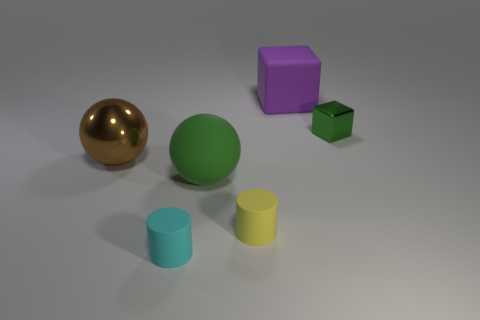There is a thing that is both left of the green shiny object and behind the large brown object; what is its size?
Your answer should be compact. Large. There is a purple block; are there any big shiny spheres to the left of it?
Keep it short and to the point. Yes. There is a large brown metal sphere left of the purple matte cube; are there any tiny matte things right of it?
Give a very brief answer. Yes. Are there an equal number of large cubes on the left side of the yellow object and small objects that are in front of the brown metal ball?
Give a very brief answer. No. There is a big sphere that is the same material as the big purple cube; what color is it?
Make the answer very short. Green. Are there any tiny cyan cylinders that have the same material as the large green sphere?
Give a very brief answer. Yes. What number of things are either small brown cubes or yellow matte cylinders?
Provide a succinct answer. 1. Is the material of the large brown sphere the same as the small cylinder that is to the right of the green matte object?
Ensure brevity in your answer.  No. What size is the rubber thing behind the big matte ball?
Your response must be concise. Large. Are there fewer red rubber blocks than green metal blocks?
Your response must be concise. Yes. 